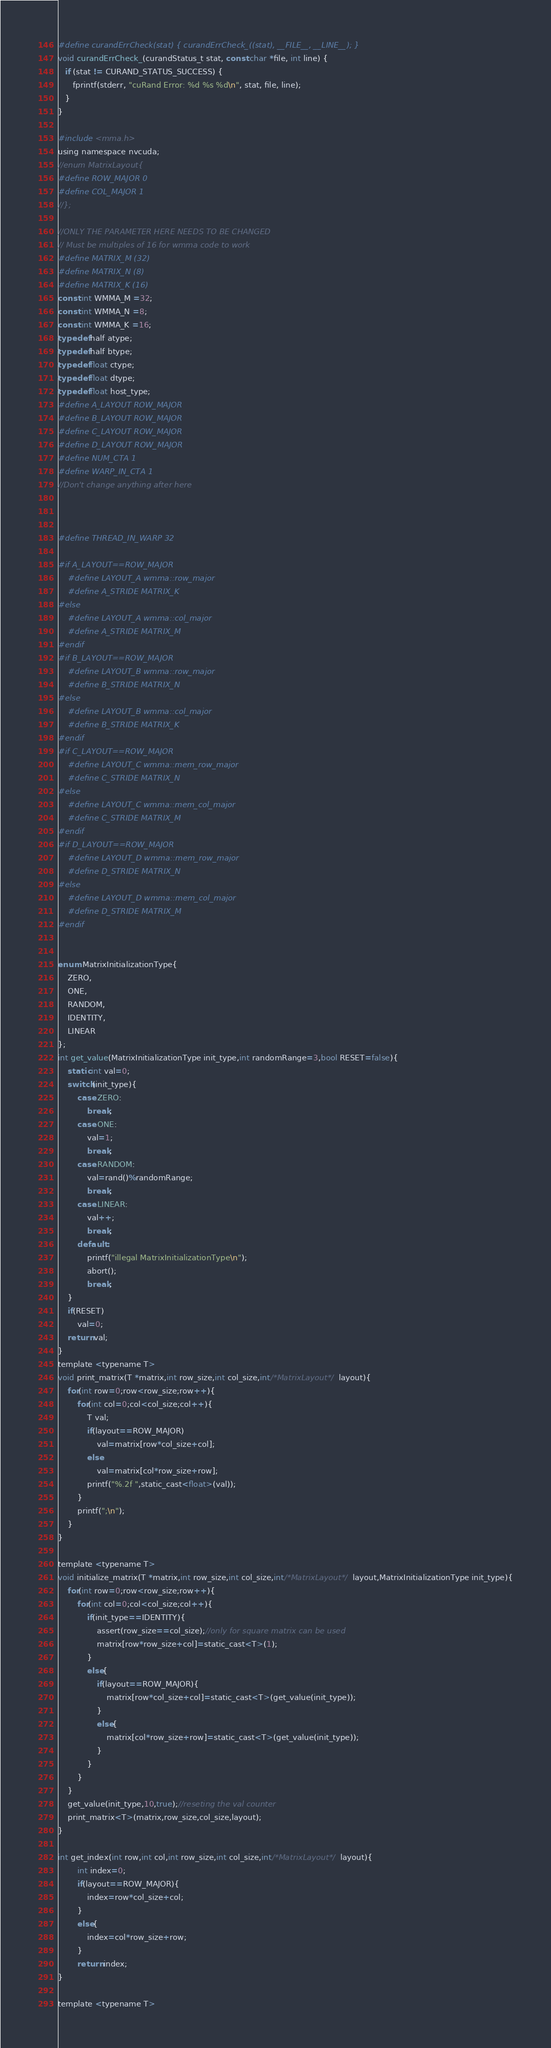Convert code to text. <code><loc_0><loc_0><loc_500><loc_500><_Cuda_>
#define curandErrCheck(stat) { curandErrCheck_((stat), __FILE__, __LINE__); }
void curandErrCheck_(curandStatus_t stat, const char *file, int line) {
   if (stat != CURAND_STATUS_SUCCESS) {
      fprintf(stderr, "cuRand Error: %d %s %d\n", stat, file, line);
   }
}

#include <mma.h>
using namespace nvcuda;
//enum MatrixLayout{
#define ROW_MAJOR 0
#define COL_MAJOR 1
//};

//ONLY THE PARAMETER HERE NEEDS TO BE CHANGED
// Must be multiples of 16 for wmma code to work
#define MATRIX_M (32)
#define MATRIX_N (8)
#define MATRIX_K (16)
const int WMMA_M =32;
const int WMMA_N =8;
const int WMMA_K =16;
typedef half atype;
typedef half btype;
typedef float ctype;
typedef float dtype;
typedef float host_type;
#define A_LAYOUT ROW_MAJOR
#define B_LAYOUT ROW_MAJOR 
#define C_LAYOUT ROW_MAJOR
#define D_LAYOUT ROW_MAJOR
#define NUM_CTA 1
#define WARP_IN_CTA 1
//Don't change anything after here 



#define THREAD_IN_WARP 32

#if A_LAYOUT==ROW_MAJOR
	#define LAYOUT_A wmma::row_major 
	#define A_STRIDE MATRIX_K
#else
	#define LAYOUT_A wmma::col_major 
	#define A_STRIDE MATRIX_M
#endif	
#if B_LAYOUT==ROW_MAJOR
	#define LAYOUT_B wmma::row_major 
	#define B_STRIDE MATRIX_N
#else
	#define LAYOUT_B wmma::col_major 
	#define B_STRIDE MATRIX_K
#endif	
#if C_LAYOUT==ROW_MAJOR
	#define LAYOUT_C wmma::mem_row_major 
	#define C_STRIDE MATRIX_N
#else
	#define LAYOUT_C wmma::mem_col_major 
	#define C_STRIDE MATRIX_M
#endif	
#if D_LAYOUT==ROW_MAJOR
	#define LAYOUT_D wmma::mem_row_major 
	#define D_STRIDE MATRIX_N
#else
	#define LAYOUT_D wmma::mem_col_major 
	#define D_STRIDE MATRIX_M
#endif	


enum MatrixInitializationType{
	ZERO,
	ONE,
	RANDOM,
	IDENTITY,
	LINEAR
};
int get_value(MatrixInitializationType init_type,int randomRange=3,bool RESET=false){
	static int val=0;
	switch(init_type){
		case ZERO:
			break;
		case ONE:
			val=1;
			break;
		case RANDOM:
			val=rand()%randomRange;
			break;
		case LINEAR:
			val++;
			break;
		default :
			printf("illegal MatrixInitializationType\n");
			abort();
			break;
	}
	if(RESET)
		val=0;
	return val;
}
template <typename T>
void print_matrix(T *matrix,int row_size,int col_size,int/*MatrixLayout*/  layout){
	for(int row=0;row<row_size;row++){
		for(int col=0;col<col_size;col++){
			T val;
			if(layout==ROW_MAJOR)
				val=matrix[row*col_size+col];		
			else
				val=matrix[col*row_size+row];
			printf("%.2f ",static_cast<float>(val));
		}
		printf(";\n");
	}
}

template <typename T>
void initialize_matrix(T *matrix,int row_size,int col_size,int/*MatrixLayout*/  layout,MatrixInitializationType init_type){
	for(int row=0;row<row_size;row++){
		for(int col=0;col<col_size;col++){
			if(init_type==IDENTITY){
				assert(row_size==col_size);//only for square matrix can be used
				matrix[row*row_size+col]=static_cast<T>(1);
			}
			else{
				if(layout==ROW_MAJOR){
					matrix[row*col_size+col]=static_cast<T>(get_value(init_type));
				}
				else{
					matrix[col*row_size+row]=static_cast<T>(get_value(init_type));
				}
			}
		}
	}
	get_value(init_type,10,true);//reseting the val counter
  	print_matrix<T>(matrix,row_size,col_size,layout);
}

int get_index(int row,int col,int row_size,int col_size,int/*MatrixLayout*/  layout){
		int index=0;
		if(layout==ROW_MAJOR){
			index=row*col_size+col;		
		}
		else{
			index=col*row_size+row;
		}
		return index;
}

template <typename T></code> 